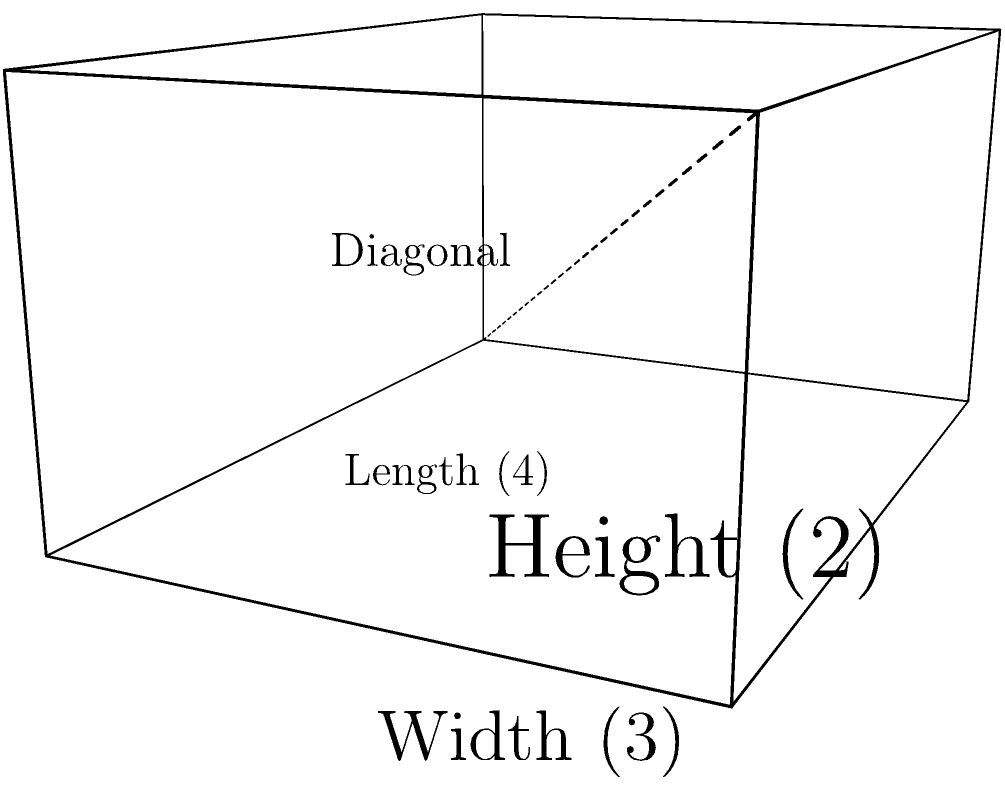As a web developer working on an RSS feed aggregator, you're tasked with creating a 3D visualization of feed sources. Each source is represented by a rectangular prism, where the length, width, and height correspond to different metrics. Given a feed source with length 4 units, width 3 units, and height 2 units, calculate the diagonal length of this rectangular prism to determine the overall importance score of the source. To calculate the diagonal length of a rectangular prism, we can use the three-dimensional extension of the Pythagorean theorem. Here's how:

1. Let's define our variables:
   $l = 4$ (length)
   $w = 3$ (width)
   $h = 2$ (height)
   $d = $ diagonal (what we're solving for)

2. The formula for the diagonal of a rectangular prism is:
   $d = \sqrt{l^2 + w^2 + h^2}$

3. Substitute the known values:
   $d = \sqrt{4^2 + 3^2 + 2^2}$

4. Calculate the squares:
   $d = \sqrt{16 + 9 + 4}$

5. Sum the values under the square root:
   $d = \sqrt{29}$

6. Simplify:
   $d = \sqrt{29} \approx 5.385$ (rounded to three decimal places)

This diagonal length represents the importance score of the feed source in your 3D visualization.
Answer: $\sqrt{29}$ units 